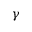Convert formula to latex. <formula><loc_0><loc_0><loc_500><loc_500>\gamma</formula> 